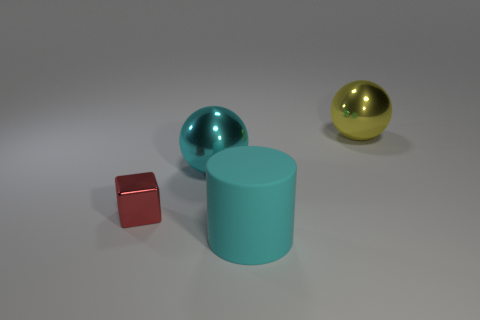Add 2 big yellow spheres. How many objects exist? 6 Subtract all cylinders. How many objects are left? 3 Subtract 0 green balls. How many objects are left? 4 Subtract all red things. Subtract all cyan spheres. How many objects are left? 2 Add 3 large things. How many large things are left? 6 Add 3 purple shiny spheres. How many purple shiny spheres exist? 3 